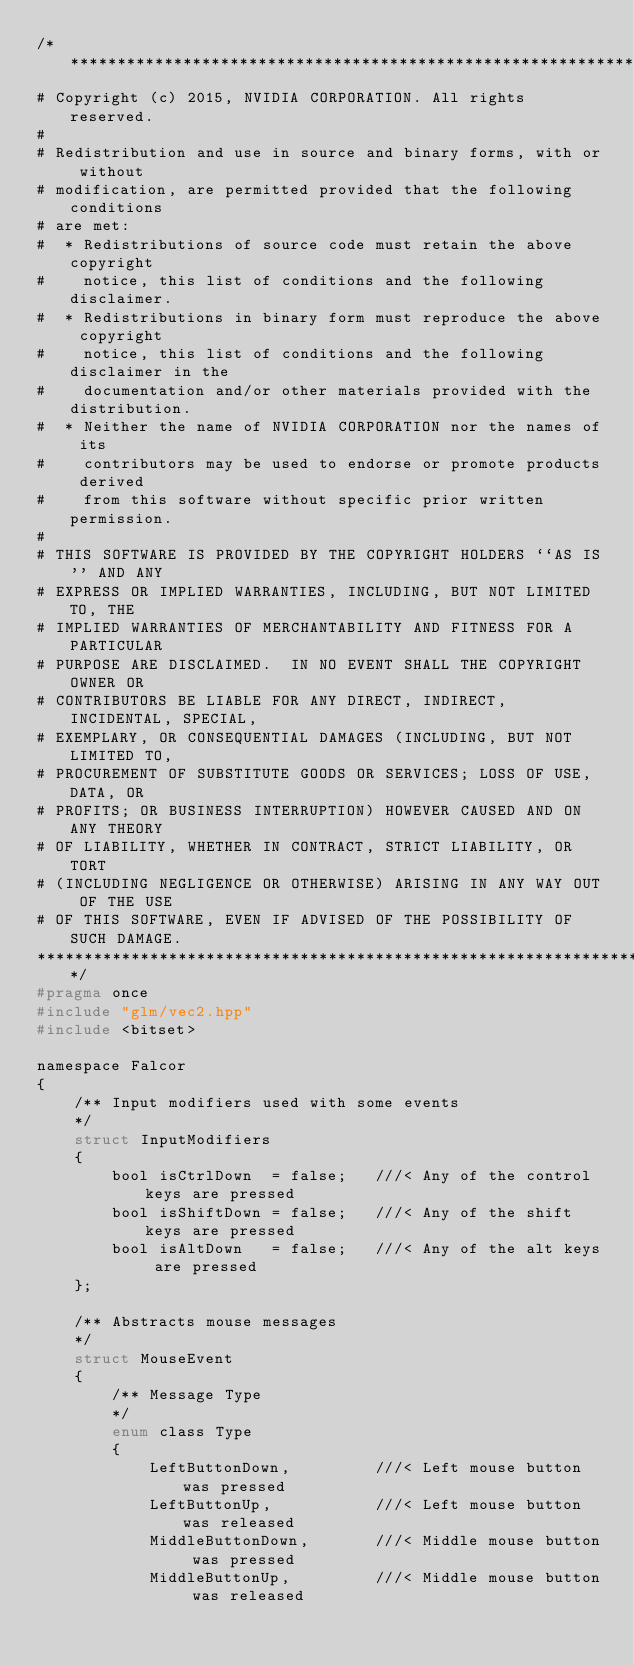Convert code to text. <code><loc_0><loc_0><loc_500><loc_500><_C_>/***************************************************************************
# Copyright (c) 2015, NVIDIA CORPORATION. All rights reserved.
#
# Redistribution and use in source and binary forms, with or without
# modification, are permitted provided that the following conditions
# are met:
#  * Redistributions of source code must retain the above copyright
#    notice, this list of conditions and the following disclaimer.
#  * Redistributions in binary form must reproduce the above copyright
#    notice, this list of conditions and the following disclaimer in the
#    documentation and/or other materials provided with the distribution.
#  * Neither the name of NVIDIA CORPORATION nor the names of its
#    contributors may be used to endorse or promote products derived
#    from this software without specific prior written permission.
#
# THIS SOFTWARE IS PROVIDED BY THE COPYRIGHT HOLDERS ``AS IS'' AND ANY
# EXPRESS OR IMPLIED WARRANTIES, INCLUDING, BUT NOT LIMITED TO, THE
# IMPLIED WARRANTIES OF MERCHANTABILITY AND FITNESS FOR A PARTICULAR
# PURPOSE ARE DISCLAIMED.  IN NO EVENT SHALL THE COPYRIGHT OWNER OR
# CONTRIBUTORS BE LIABLE FOR ANY DIRECT, INDIRECT, INCIDENTAL, SPECIAL,
# EXEMPLARY, OR CONSEQUENTIAL DAMAGES (INCLUDING, BUT NOT LIMITED TO,
# PROCUREMENT OF SUBSTITUTE GOODS OR SERVICES; LOSS OF USE, DATA, OR
# PROFITS; OR BUSINESS INTERRUPTION) HOWEVER CAUSED AND ON ANY THEORY
# OF LIABILITY, WHETHER IN CONTRACT, STRICT LIABILITY, OR TORT
# (INCLUDING NEGLIGENCE OR OTHERWISE) ARISING IN ANY WAY OUT OF THE USE
# OF THIS SOFTWARE, EVEN IF ADVISED OF THE POSSIBILITY OF SUCH DAMAGE.
***************************************************************************/
#pragma once
#include "glm/vec2.hpp"
#include <bitset>

namespace Falcor
{    
    /** Input modifiers used with some events
    */
    struct InputModifiers
    {
        bool isCtrlDown  = false;   ///< Any of the control keys are pressed
        bool isShiftDown = false;   ///< Any of the shift keys are pressed
        bool isAltDown   = false;   ///< Any of the alt keys are pressed
    };

    /** Abstracts mouse messages
    */
    struct MouseEvent
    {
        /** Message Type
        */
        enum class Type
        {
            LeftButtonDown,         ///< Left mouse button was pressed
            LeftButtonUp,           ///< Left mouse button was released
            MiddleButtonDown,       ///< Middle mouse button was pressed
            MiddleButtonUp,         ///< Middle mouse button was released</code> 